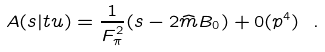<formula> <loc_0><loc_0><loc_500><loc_500>A ( s | t u ) = \frac { 1 } { F ^ { 2 } _ { \pi } } ( s - 2 \widehat { m } B _ { 0 } ) + 0 ( p ^ { 4 } ) \ .</formula> 